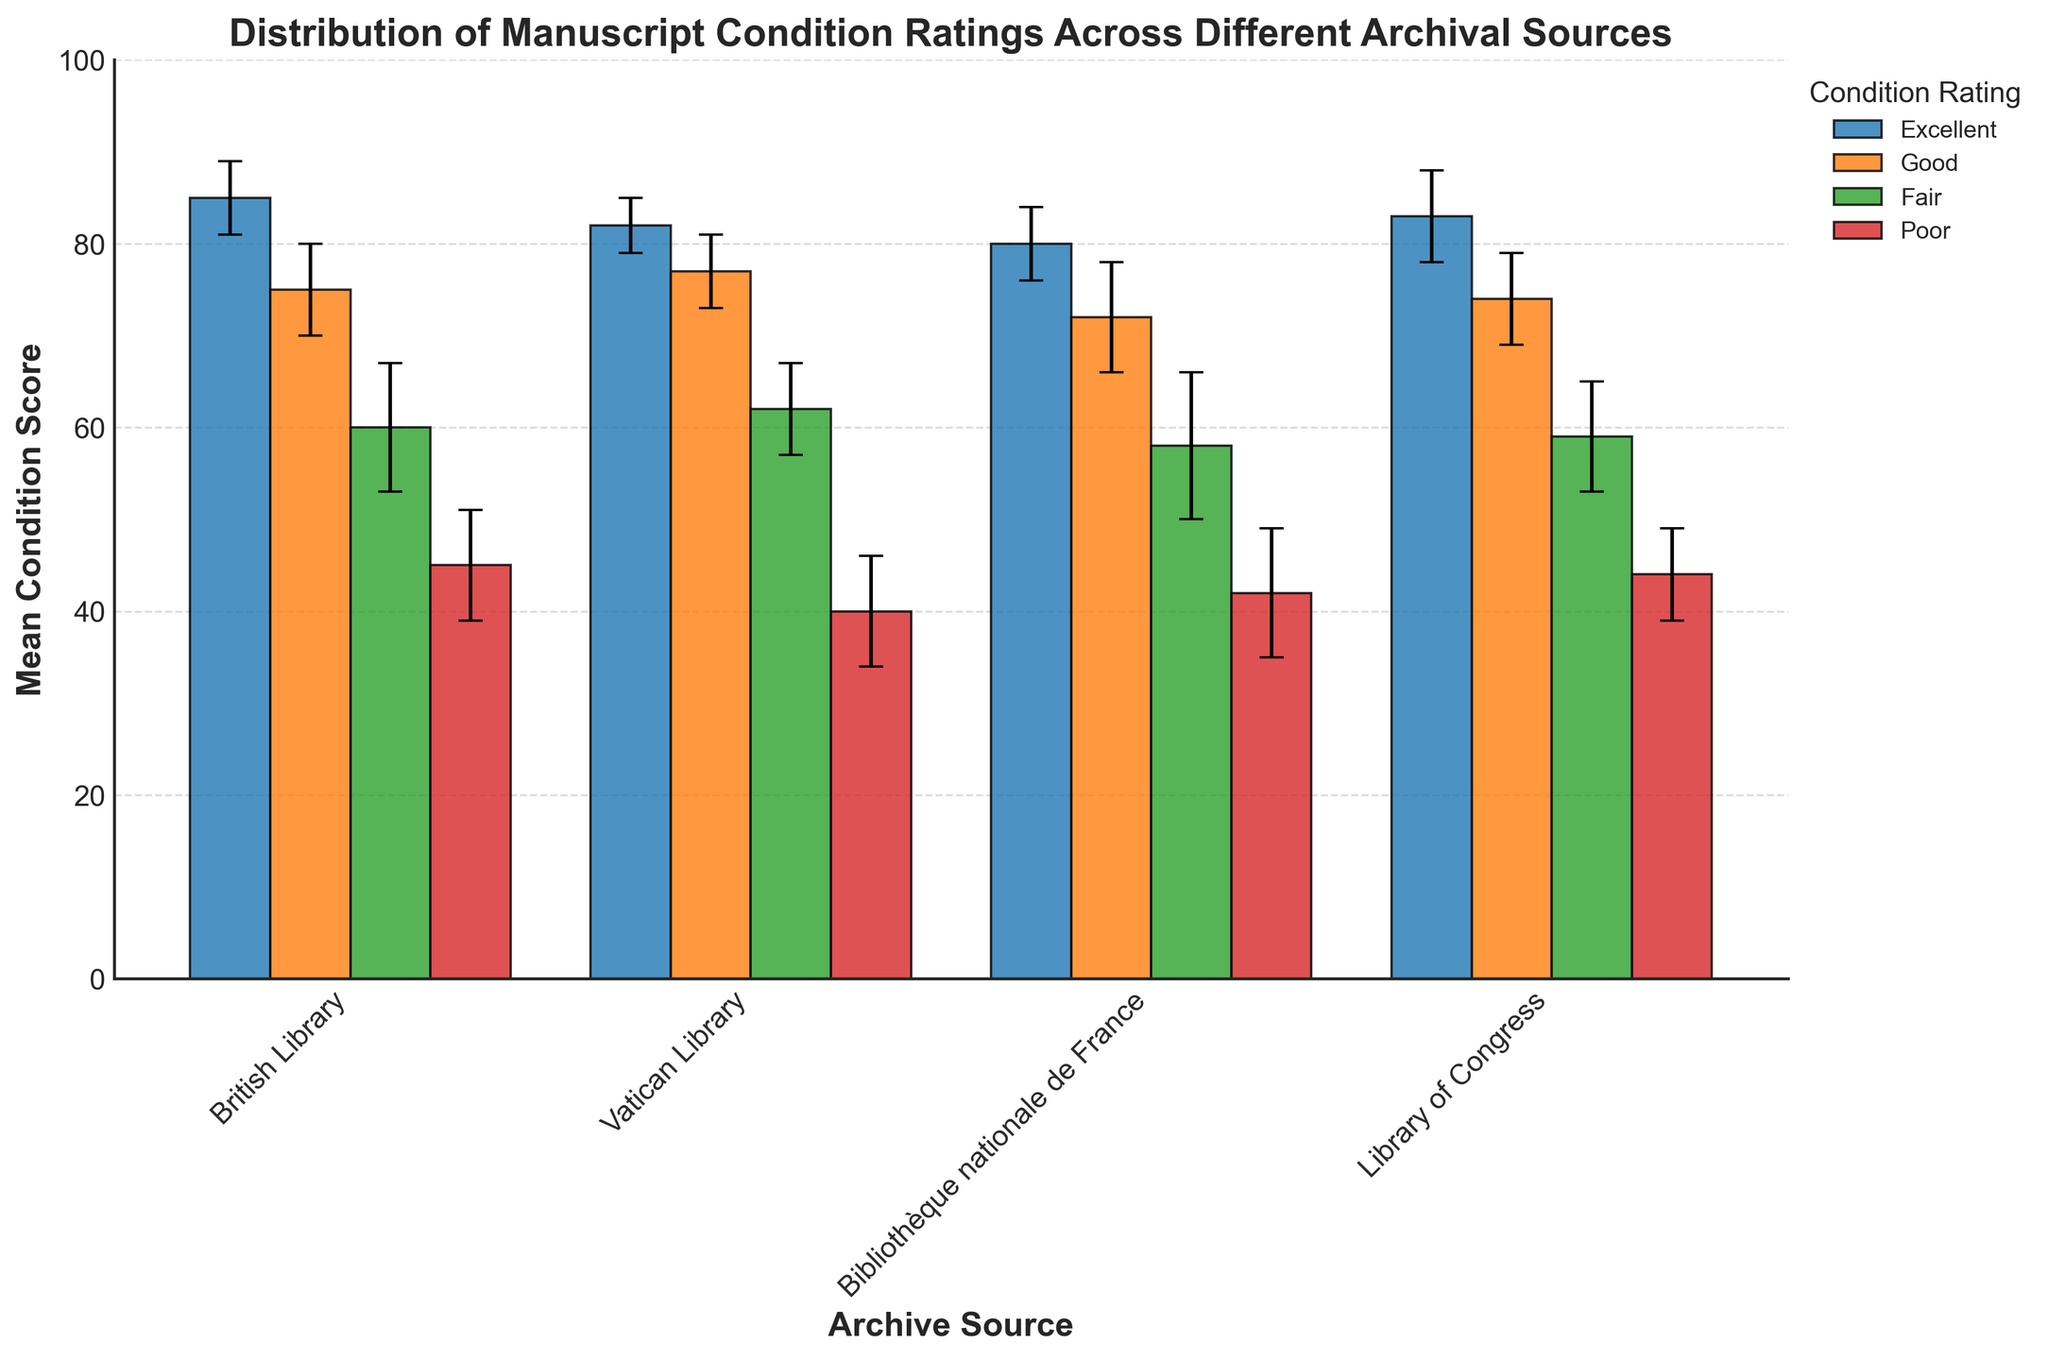How many sources of archives are represented in the figure? The x-axis displays the archive sources. By counting the distinct labels on the x-axis, we can determine the number of sources.
Answer: 4 Which archive has the highest mean condition score for 'Excellent' manuscripts, and what is that score? Observing the heights of the bars labeled 'Excellent' across all archive sources, the highest bar represents the highest mean score. The corresponding archive is identified by the x-axis label. The mean score is indicated by the height of the bar.
Answer: British Library, 85 What is the difference in the mean condition score for 'Fair' manuscripts between the British Library and the Bibliothèque nationale de France? First, locate the bars for 'Fair' manuscripts for both archive sources. Subtract the mean score of the British Library's 'Fair' manuscripts from that of the Bibliothèque nationale de France.
Answer: 60 - 58 = 2 What is the average mean condition score of 'Poor' manuscripts across all four archival sources? Add up the mean condition scores of 'Poor' manuscripts for all four archival sources and divide by the number of sources. (45 + 40 + 42 + 44) / 4.
Answer: 42.75 Which condition rating has the largest range of mean condition scores across the four archival sources? For each condition rating, determine the highest score and lowest score across all archive sources. Subtract the lowest score from the highest score for each condition rating. Identify the condition rating with the largest resultant difference. Excellent: 85 - 80 = 5, Good: 77 - 72 = 5, Fair: 62 - 58 = 4, Poor: 45 - 40 = 5.
Answer: Excellent, Good, and Poor Which archival source has the smallest standard deviation for 'Good' manuscripts? Each bar has an associated error bar representing the standard deviation. Compare the lengths of the error bars for 'Good' manuscripts across all archival sources. The smallest error bar indicates the smallest standard deviation.
Answer: Vatican Library Considering the error bars, are the mean condition scores for 'Excellent' manuscripts statistically significantly different between the British Library and the Vatican Library? Check the overlap of the error bars of the 'Excellent' manuscripts for the British Library and the Vatican Library. If the error bars do not overlap, the mean scores are statistically significantly different.
Answer: No (they overlap) On average, which archival source has the highest mean condition score across all condition ratings? Sum mean scores across all conditions for each archive and divide by the number of condition ratings (4). Compare the average scores. British Library: (85+75+60+45)/4 = 66.25, Vatican Library: (82+77+62+40)/4 = 65.25, Bibliothèque nationale de France: (80+72+58+42)/4 = 63, Library of Congress: (83+74+59+44)/4 = 65.
Answer: British Library 